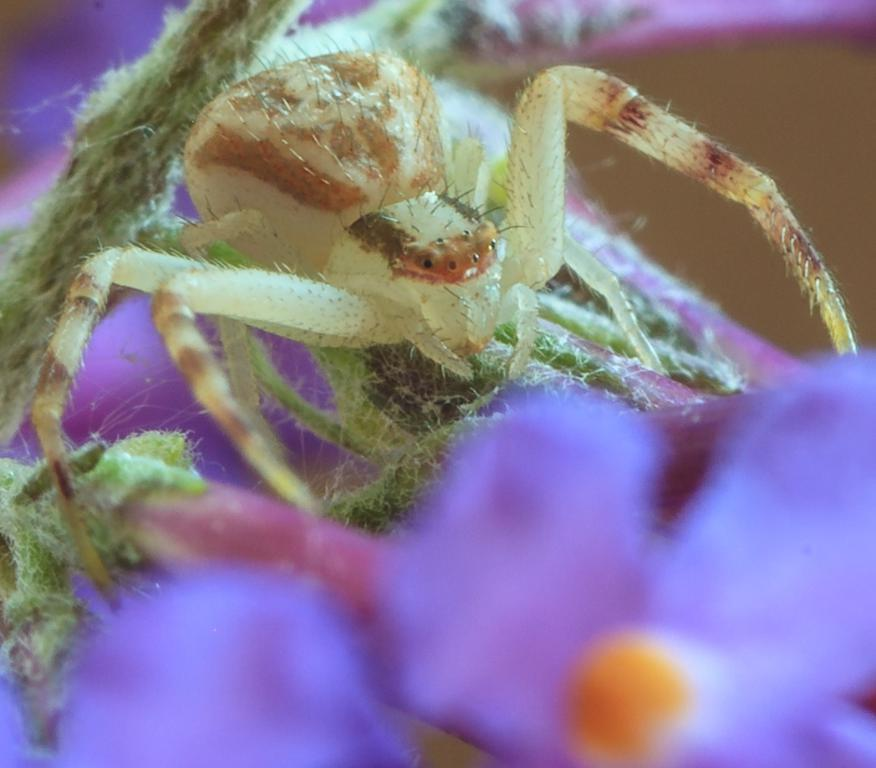What type of creature can be seen in the image? There is an insect in the image. What is located on the right side of the image? There is a flower on the right side of the image. What is the weight of the fork in the image? There is no fork present in the image, so it is not possible to determine its weight. 